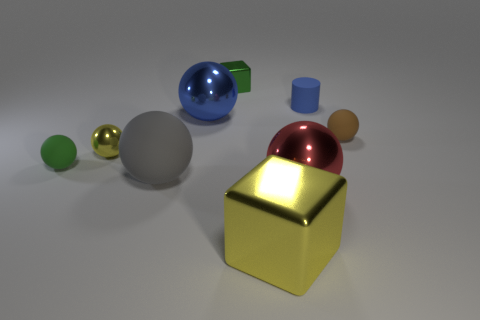What is the shape of the small thing that is the same color as the large metallic cube?
Ensure brevity in your answer.  Sphere. How big is the cube in front of the blue matte thing that is on the right side of the yellow ball that is on the left side of the blue cylinder?
Give a very brief answer. Large. What is the cylinder made of?
Provide a succinct answer. Rubber. Do the gray sphere and the tiny sphere right of the big yellow thing have the same material?
Offer a very short reply. Yes. Is there anything else that is the same color as the large cube?
Provide a short and direct response. Yes. There is a green thing to the right of the small green object that is in front of the brown matte sphere; is there a large red thing that is in front of it?
Offer a terse response. Yes. What color is the cylinder?
Offer a very short reply. Blue. Are there any tiny green things behind the brown ball?
Provide a short and direct response. Yes. There is a small brown matte object; is its shape the same as the small rubber object left of the big red object?
Offer a very short reply. Yes. What number of other things are there of the same material as the big gray ball
Your answer should be very brief. 3. 